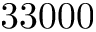Convert formula to latex. <formula><loc_0><loc_0><loc_500><loc_500>3 3 0 0 0</formula> 